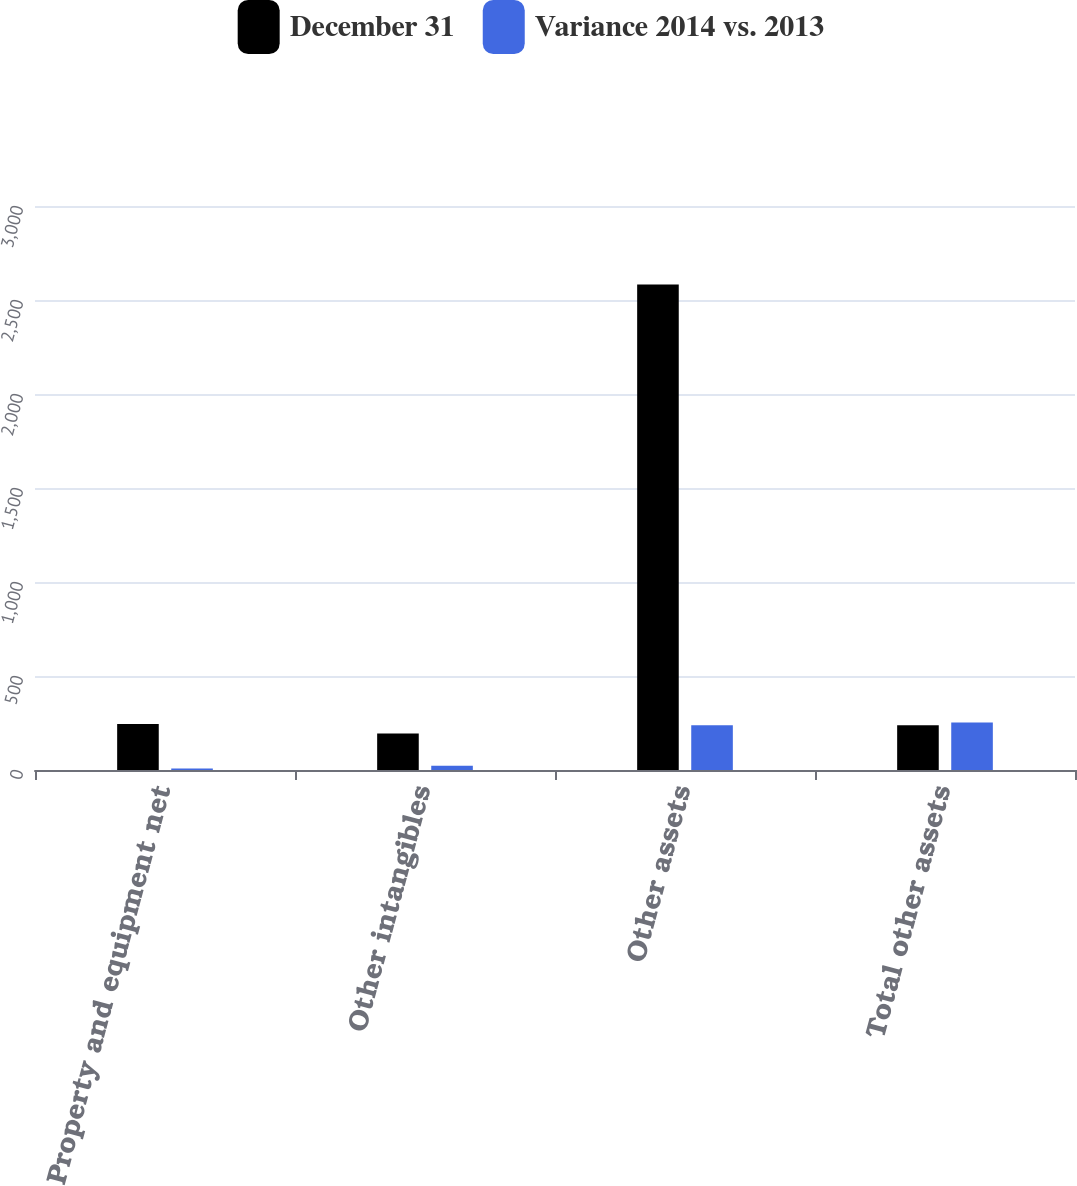<chart> <loc_0><loc_0><loc_500><loc_500><stacked_bar_chart><ecel><fcel>Property and equipment net<fcel>Other intangibles<fcel>Other assets<fcel>Total other assets<nl><fcel>December 31<fcel>245<fcel>194<fcel>2583<fcel>238<nl><fcel>Variance 2014 vs. 2013<fcel>8<fcel>22<fcel>238<fcel>252<nl></chart> 